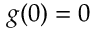Convert formula to latex. <formula><loc_0><loc_0><loc_500><loc_500>g ( 0 ) = 0</formula> 